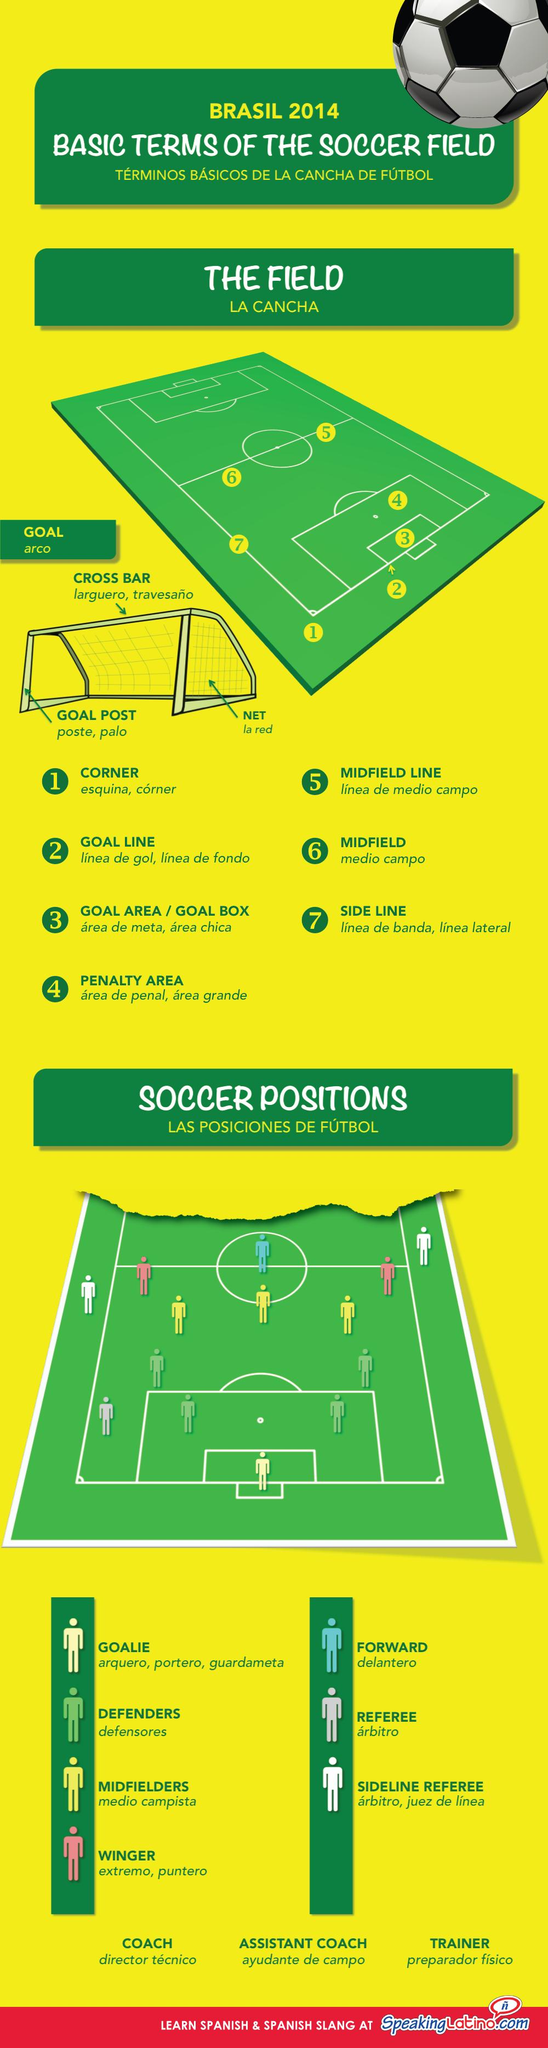Indicate a few pertinent items in this graphic. The color of the football field is green. The winger is shown in pink. The top beam of the goal post is called a cross bar in English. Brazilians refer to the field as "la cancha. In Brazilian Portuguese, the midfield is commonly referred to as "meio-campo. 